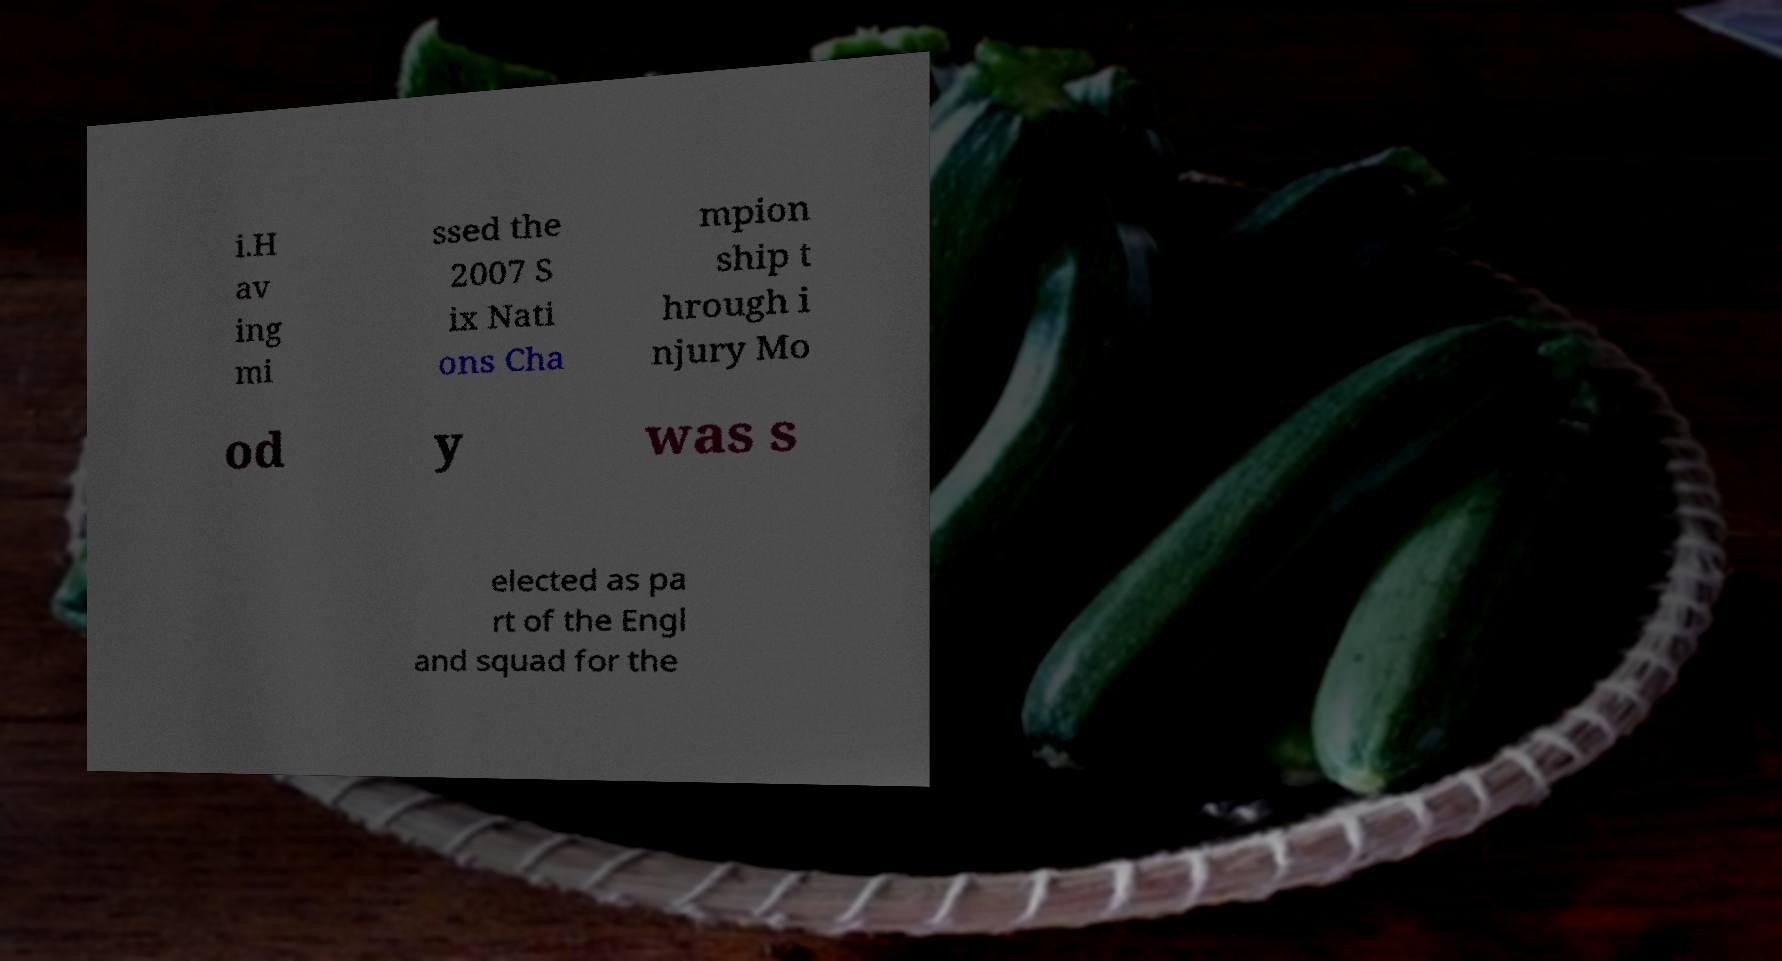Can you read and provide the text displayed in the image?This photo seems to have some interesting text. Can you extract and type it out for me? i.H av ing mi ssed the 2007 S ix Nati ons Cha mpion ship t hrough i njury Mo od y was s elected as pa rt of the Engl and squad for the 